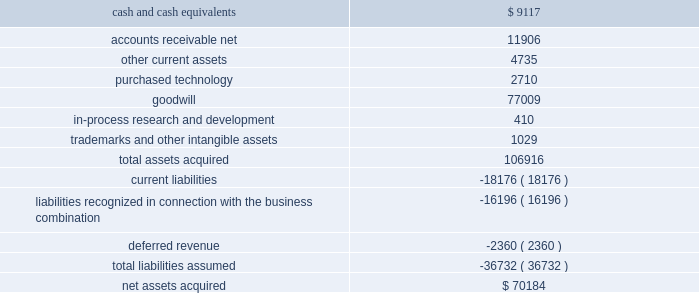2003 and for hedging relationships designated after june 30 , 2003 .
The adoption of sfas 149 did not have a material impact on our consolidated financial position , results of operations or cash flows .
In may 2003 , the fasb issued statement of financial accounting standards no .
150 ( 201csfas 150 201d ) , 201caccounting for certain financial instruments with characteristics of both liabilities and equity . 201d sfas 150 requires that certain financial instruments , which under previous guidance were accounted for as equity , must now be accounted for as liabilities .
The financial instruments affected include mandatory redeemable stock , certain financial instruments that require or may require the issuer to buy back some of its shares in exchange for cash or other assets and certain obligations that can be settled with shares of stock .
Sfas 150 is effective for all financial instruments entered into or modified after may 31 , 2003 , and otherwise is effective at the beginning of the first interim period beginning after june 15 , 2003 .
The adoption of sfas 150 did not have a material impact on our consolidated financial position , results of operations or cash flows .
Note 2 .
Acquisitions on may 19 , 2003 , we purchased the technology assets of syntrillium , a privately held company , for $ 16.5 million cash .
Syntrillium developed , published and marketed digital audio tools including its recording application , cool edit pro ( renamed adobe audition ) , all of which have been added to our existing line of professional digital imaging and video products .
By adding adobe audition and the other tools to our existing line of products , we have improved the adobe video workflow and expanded the products and tools available to videographers , dvd authors and independent filmmakers .
In connection with the purchase , we allocated $ 13.7 million to goodwill , $ 2.7 million to purchased technology and $ 0.1 million to tangible assets .
We also accrued $ 0.1 million in acquisition-related legal and accounting fees .
Goodwill has been allocated to our digital imaging and video segment .
Purchased technology is being amortized to cost of product revenue over its estimated useful life of three years .
The consolidated financial statements include the operating results of the purchased technology assets from the date of purchase .
Pro forma results of operations have not been presented because the effect of this acquisition was not material .
In april 2002 , we acquired all of the outstanding common stock of accelio .
Accelio was a provider of web-enabled solutions that helped customers manage business processes driven by electronic forms .
The acquisition of accelio broadened our epaper solution business .
At the date of acquisition , the aggregate purchase price was $ 70.2 million , which included the issuance of 1.8 million shares of common stock of adobe , valued at $ 68.4 million , and cash of $ 1.8 million .
The table summarizes the purchase price allocation: .
We allocated $ 2.7 million to purchased technology and $ 0.4 million to in-process research and development .
The amount allocated to purchased technology represented the fair market value of the technology for each of the existing products , as of the date of the acquisition .
The purchased technology was assigned a useful life of three years and is being amortized to cost of product revenue .
The amount allocated to in-process research and development was expensed at the time of acquisition due to the state of the development of certain products and the uncertainty of the technology .
The remaining purchase price was allocated to goodwill and was assigned to our epaper segment ( which was renamed intelligent documents beginning in fiscal 2004 ) .
In accordance with sfas no .
142 .
What portion of total liability assumed from accelio was reported as current liabilities? 
Computations: (18176 / 36732)
Answer: 0.49483. 